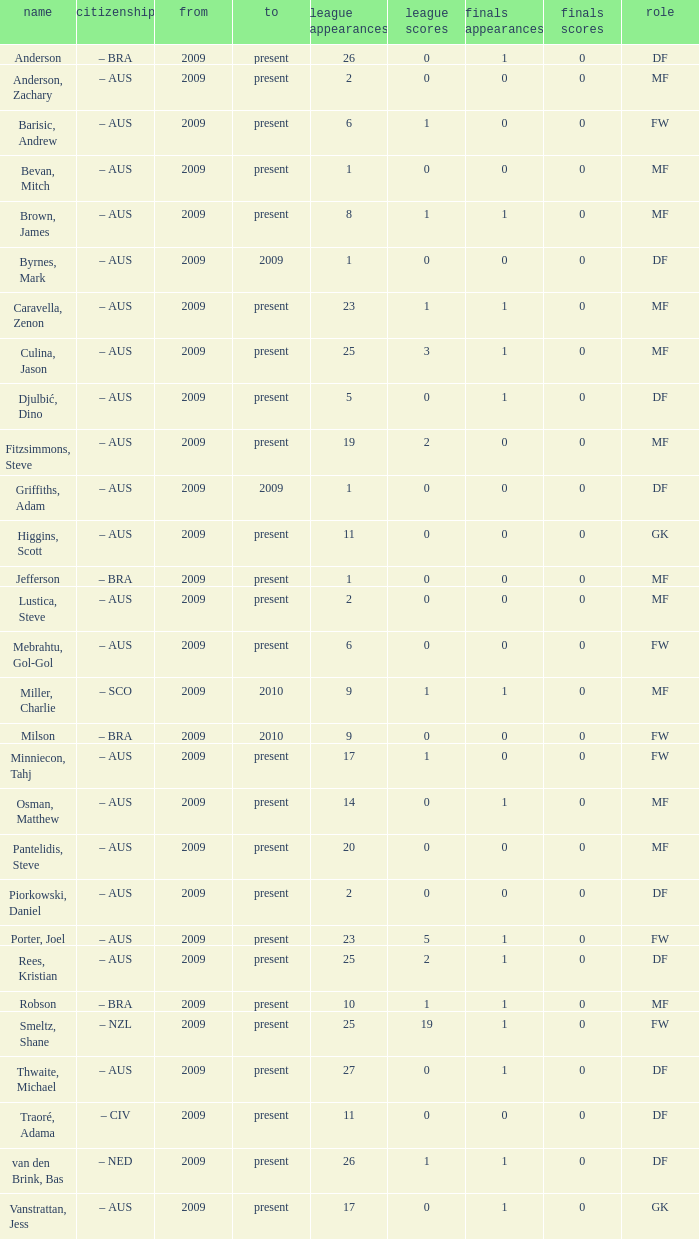Name the to for 19 league apps Present. 